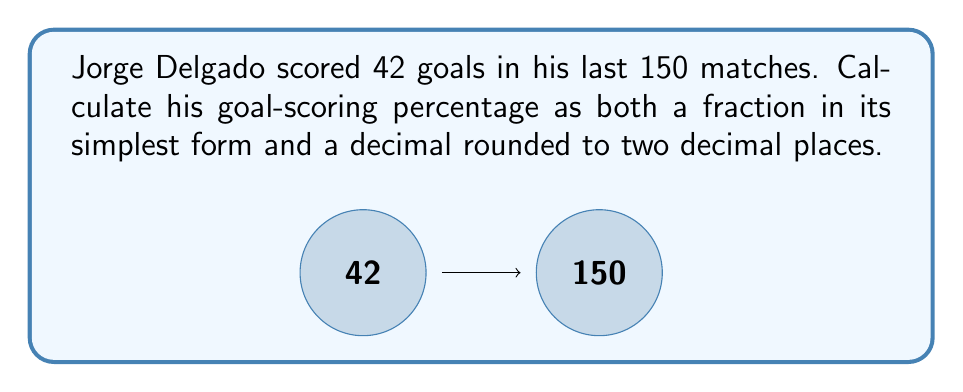Solve this math problem. Let's approach this step-by-step:

1) First, we need to express Jorge's goal-scoring as a fraction:
   $\frac{\text{Number of goals scored}}{\text{Total number of matches}} = \frac{42}{150}$

2) To simplify this fraction, we need to find the greatest common divisor (GCD) of 42 and 150:
   $GCD(42, 150) = 6$

3) Dividing both the numerator and denominator by 6:
   $\frac{42 \div 6}{150 \div 6} = \frac{7}{25}$

4) This is the simplified fraction. Now, to convert this to a decimal:
   $\frac{7}{25} = 7 \div 25 = 0.28$

5) To calculate the percentage, we multiply the decimal by 100:
   $0.28 \times 100 = 28\%$

Therefore, Jorge Delgado's goal-scoring percentage is $\frac{7}{25}$ as a fraction, or 0.28 (28%) as a decimal.
Answer: $\frac{7}{25}$ or 0.28 